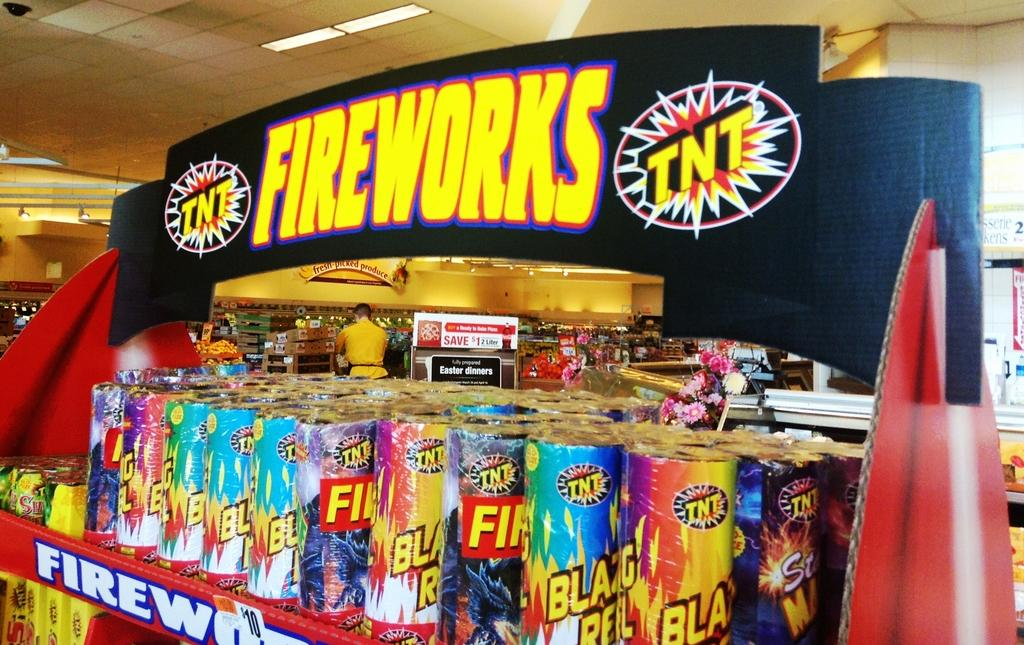<image>
Offer a succinct explanation of the picture presented. Fireworks TNT displayed on a store shelf for the 4th of July. 